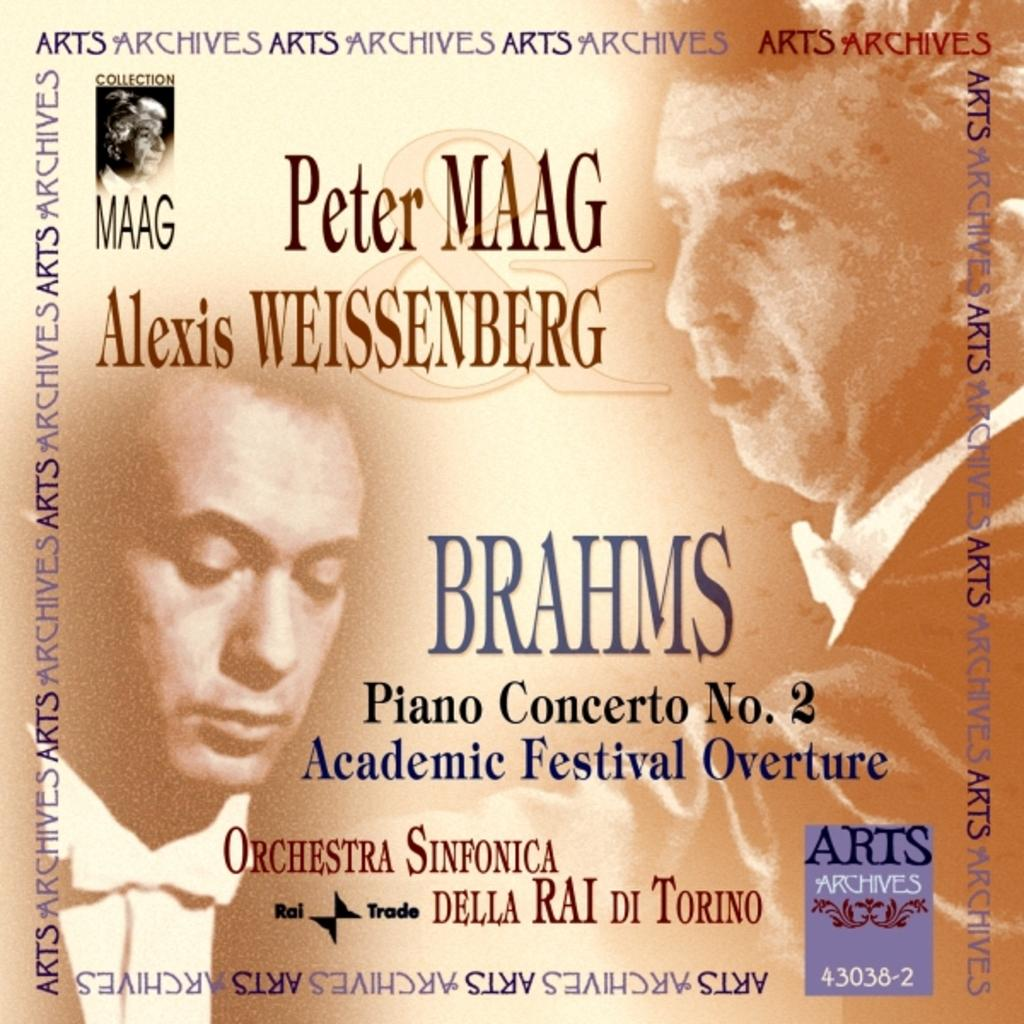What type of figures are present in the image? There are printed persons in the image. What else can be found in the image besides the printed persons? There is text printed in the image. What ideas are being discussed by the committee in the image? There is no committee or discussion of ideas present in the image; it only features printed persons and text. 